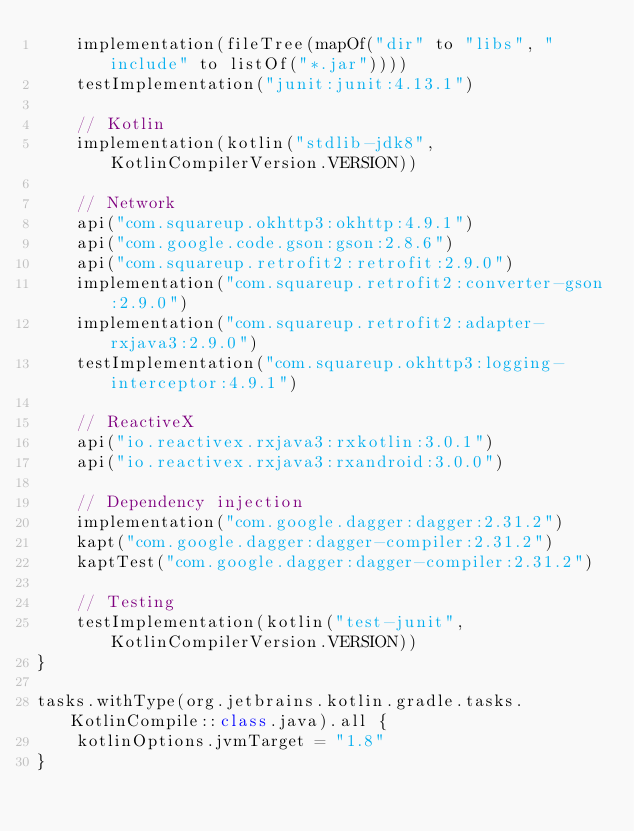<code> <loc_0><loc_0><loc_500><loc_500><_Kotlin_>    implementation(fileTree(mapOf("dir" to "libs", "include" to listOf("*.jar"))))
    testImplementation("junit:junit:4.13.1")

    // Kotlin
    implementation(kotlin("stdlib-jdk8", KotlinCompilerVersion.VERSION))

    // Network
    api("com.squareup.okhttp3:okhttp:4.9.1")
    api("com.google.code.gson:gson:2.8.6")
    api("com.squareup.retrofit2:retrofit:2.9.0")
    implementation("com.squareup.retrofit2:converter-gson:2.9.0")
    implementation("com.squareup.retrofit2:adapter-rxjava3:2.9.0")
    testImplementation("com.squareup.okhttp3:logging-interceptor:4.9.1")

    // ReactiveX
    api("io.reactivex.rxjava3:rxkotlin:3.0.1")
    api("io.reactivex.rxjava3:rxandroid:3.0.0")

    // Dependency injection
    implementation("com.google.dagger:dagger:2.31.2")
    kapt("com.google.dagger:dagger-compiler:2.31.2")
    kaptTest("com.google.dagger:dagger-compiler:2.31.2")

    // Testing
    testImplementation(kotlin("test-junit", KotlinCompilerVersion.VERSION))
}

tasks.withType(org.jetbrains.kotlin.gradle.tasks.KotlinCompile::class.java).all {
    kotlinOptions.jvmTarget = "1.8"
}
</code> 